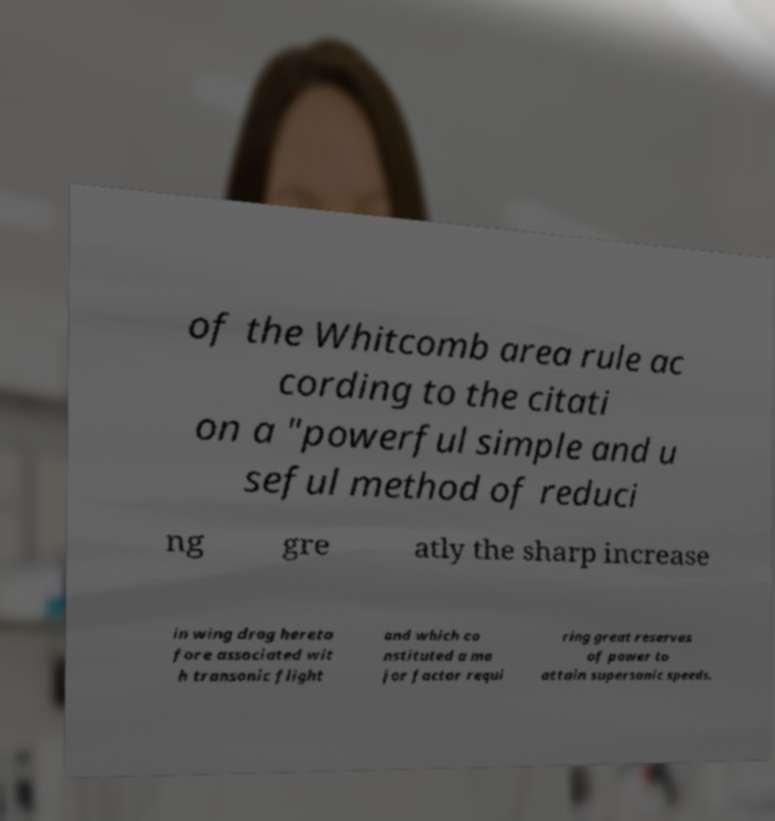Can you read and provide the text displayed in the image?This photo seems to have some interesting text. Can you extract and type it out for me? of the Whitcomb area rule ac cording to the citati on a "powerful simple and u seful method of reduci ng gre atly the sharp increase in wing drag hereto fore associated wit h transonic flight and which co nstituted a ma jor factor requi ring great reserves of power to attain supersonic speeds. 